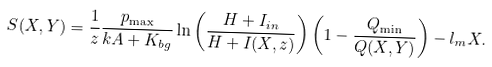<formula> <loc_0><loc_0><loc_500><loc_500>S ( X , Y ) = \frac { 1 } { z } \frac { p _ { \max } } { k A + K _ { b g } } \ln \left ( \frac { H + I _ { i n } } { H + I ( X , z ) } \right ) \left ( 1 - \frac { Q _ { \min } } { Q ( X , Y ) } \right ) - l _ { m } X .</formula> 